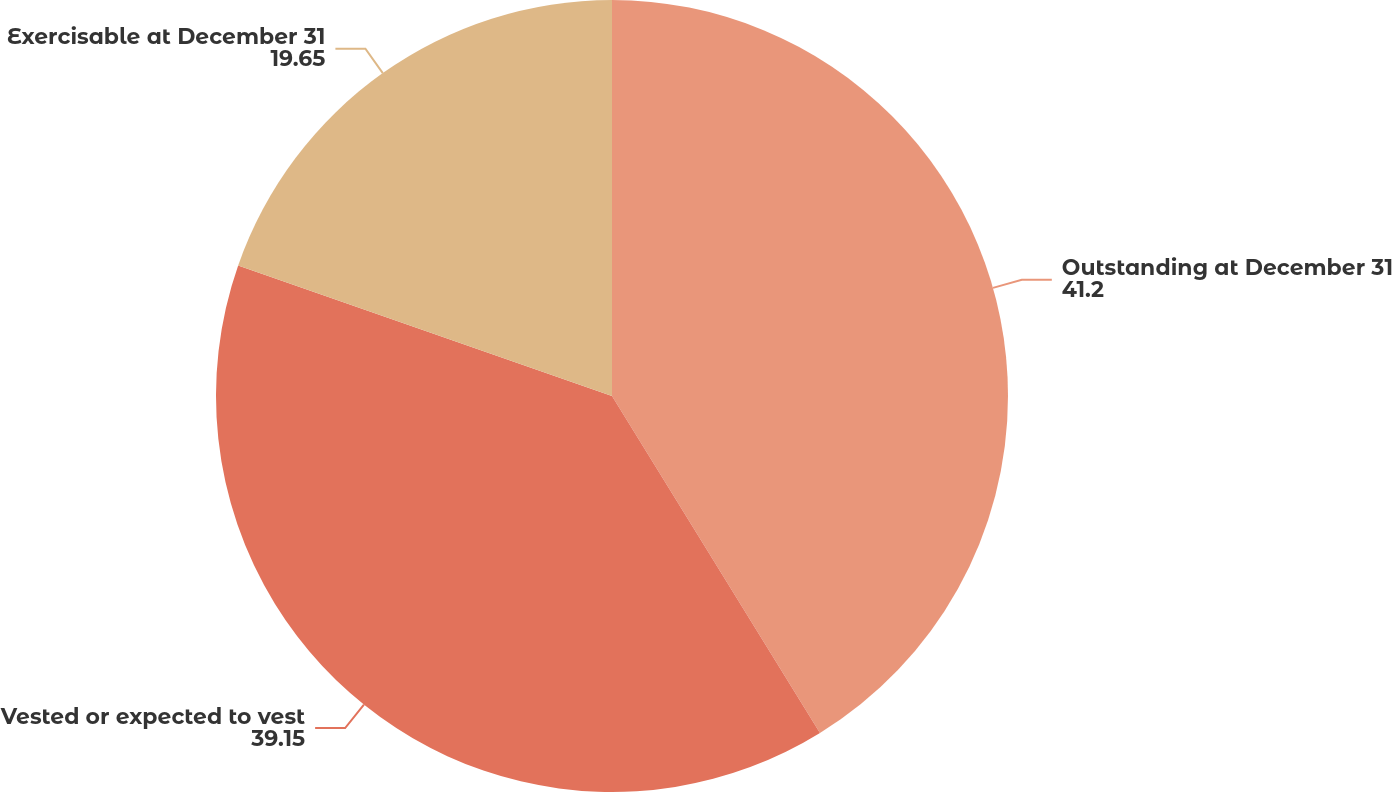Convert chart to OTSL. <chart><loc_0><loc_0><loc_500><loc_500><pie_chart><fcel>Outstanding at December 31<fcel>Vested or expected to vest<fcel>Exercisable at December 31<nl><fcel>41.2%<fcel>39.15%<fcel>19.65%<nl></chart> 